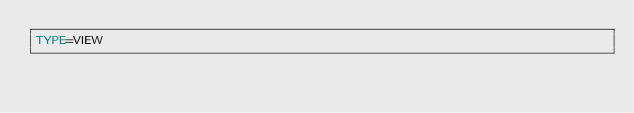Convert code to text. <code><loc_0><loc_0><loc_500><loc_500><_VisualBasic_>TYPE=VIEW</code> 